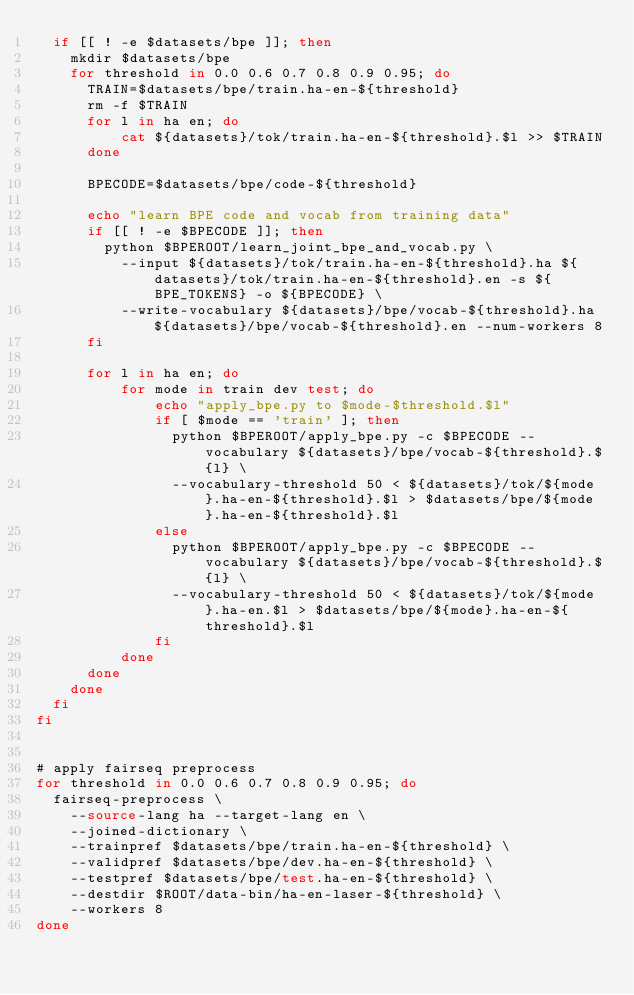Convert code to text. <code><loc_0><loc_0><loc_500><loc_500><_Bash_>  if [[ ! -e $datasets/bpe ]]; then
    mkdir $datasets/bpe
    for threshold in 0.0 0.6 0.7 0.8 0.9 0.95; do
      TRAIN=$datasets/bpe/train.ha-en-${threshold}
      rm -f $TRAIN
      for l in ha en; do
          cat ${datasets}/tok/train.ha-en-${threshold}.$l >> $TRAIN
      done

      BPECODE=$datasets/bpe/code-${threshold}

      echo "learn BPE code and vocab from training data"
      if [[ ! -e $BPECODE ]]; then
        python $BPEROOT/learn_joint_bpe_and_vocab.py \
          --input ${datasets}/tok/train.ha-en-${threshold}.ha ${datasets}/tok/train.ha-en-${threshold}.en -s ${BPE_TOKENS} -o ${BPECODE} \
          --write-vocabulary ${datasets}/bpe/vocab-${threshold}.ha ${datasets}/bpe/vocab-${threshold}.en --num-workers 8
      fi

      for l in ha en; do
          for mode in train dev test; do
              echo "apply_bpe.py to $mode-$threshold.$l"
              if [ $mode == 'train' ]; then
                python $BPEROOT/apply_bpe.py -c $BPECODE --vocabulary ${datasets}/bpe/vocab-${threshold}.${l} \
                --vocabulary-threshold 50 < ${datasets}/tok/${mode}.ha-en-${threshold}.$l > $datasets/bpe/${mode}.ha-en-${threshold}.$l
              else
                python $BPEROOT/apply_bpe.py -c $BPECODE --vocabulary ${datasets}/bpe/vocab-${threshold}.${l} \
                --vocabulary-threshold 50 < ${datasets}/tok/${mode}.ha-en.$l > $datasets/bpe/${mode}.ha-en-${threshold}.$l
              fi
          done
      done
    done
  fi
fi


# apply fairseq preprocess
for threshold in 0.0 0.6 0.7 0.8 0.9 0.95; do
  fairseq-preprocess \
    --source-lang ha --target-lang en \
    --joined-dictionary \
    --trainpref $datasets/bpe/train.ha-en-${threshold} \
    --validpref $datasets/bpe/dev.ha-en-${threshold} \
    --testpref $datasets/bpe/test.ha-en-${threshold} \
    --destdir $ROOT/data-bin/ha-en-laser-${threshold} \
    --workers 8
done</code> 